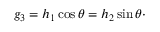<formula> <loc_0><loc_0><loc_500><loc_500>g _ { 3 } = h _ { 1 } \cos \theta = h _ { 2 } \sin \theta \cdot</formula> 